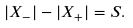Convert formula to latex. <formula><loc_0><loc_0><loc_500><loc_500>| X _ { - } | - | X _ { + } | = S .</formula> 